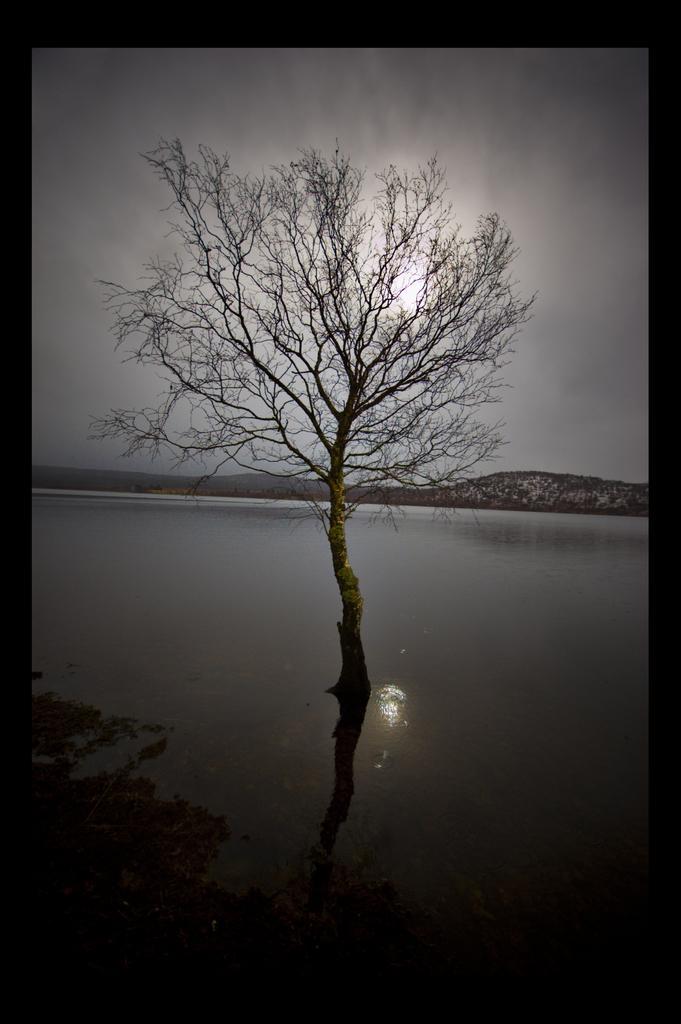Could you give a brief overview of what you see in this image? In this image I see a tree in the water and in the background I see the sky which is a bit dark. 